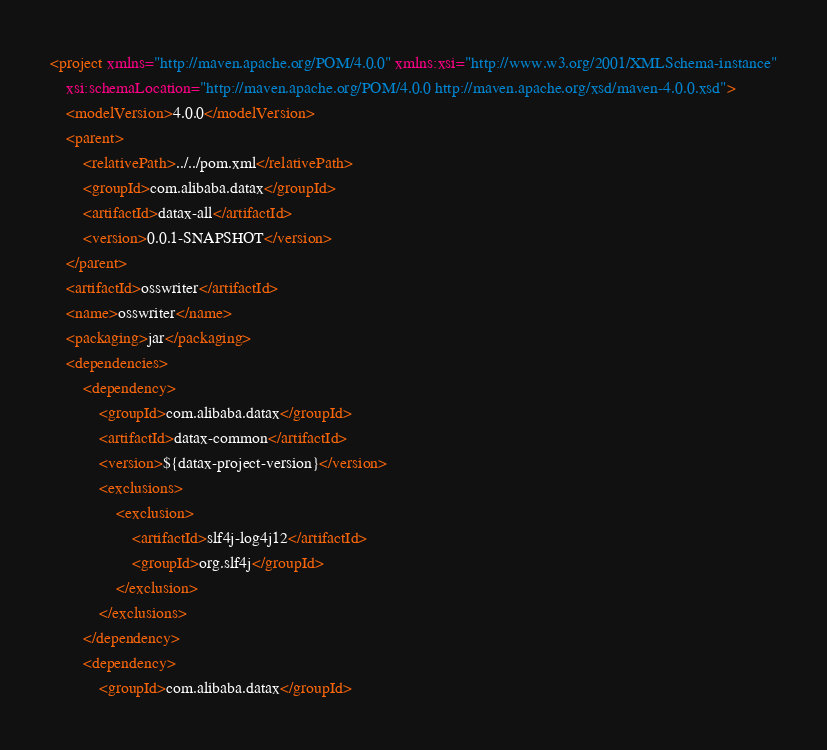<code> <loc_0><loc_0><loc_500><loc_500><_XML_><project xmlns="http://maven.apache.org/POM/4.0.0" xmlns:xsi="http://www.w3.org/2001/XMLSchema-instance"
	xsi:schemaLocation="http://maven.apache.org/POM/4.0.0 http://maven.apache.org/xsd/maven-4.0.0.xsd">
	<modelVersion>4.0.0</modelVersion>
	<parent>
        <relativePath>../../pom.xml</relativePath>
		<groupId>com.alibaba.datax</groupId>
		<artifactId>datax-all</artifactId>
		<version>0.0.1-SNAPSHOT</version>
	</parent>
	<artifactId>osswriter</artifactId>
	<name>osswriter</name>
	<packaging>jar</packaging>
	<dependencies>
		<dependency>
			<groupId>com.alibaba.datax</groupId>
			<artifactId>datax-common</artifactId>
			<version>${datax-project-version}</version>
			<exclusions>
				<exclusion>
					<artifactId>slf4j-log4j12</artifactId>
					<groupId>org.slf4j</groupId>
				</exclusion>
			</exclusions>
		</dependency>
		<dependency>
			<groupId>com.alibaba.datax</groupId></code> 